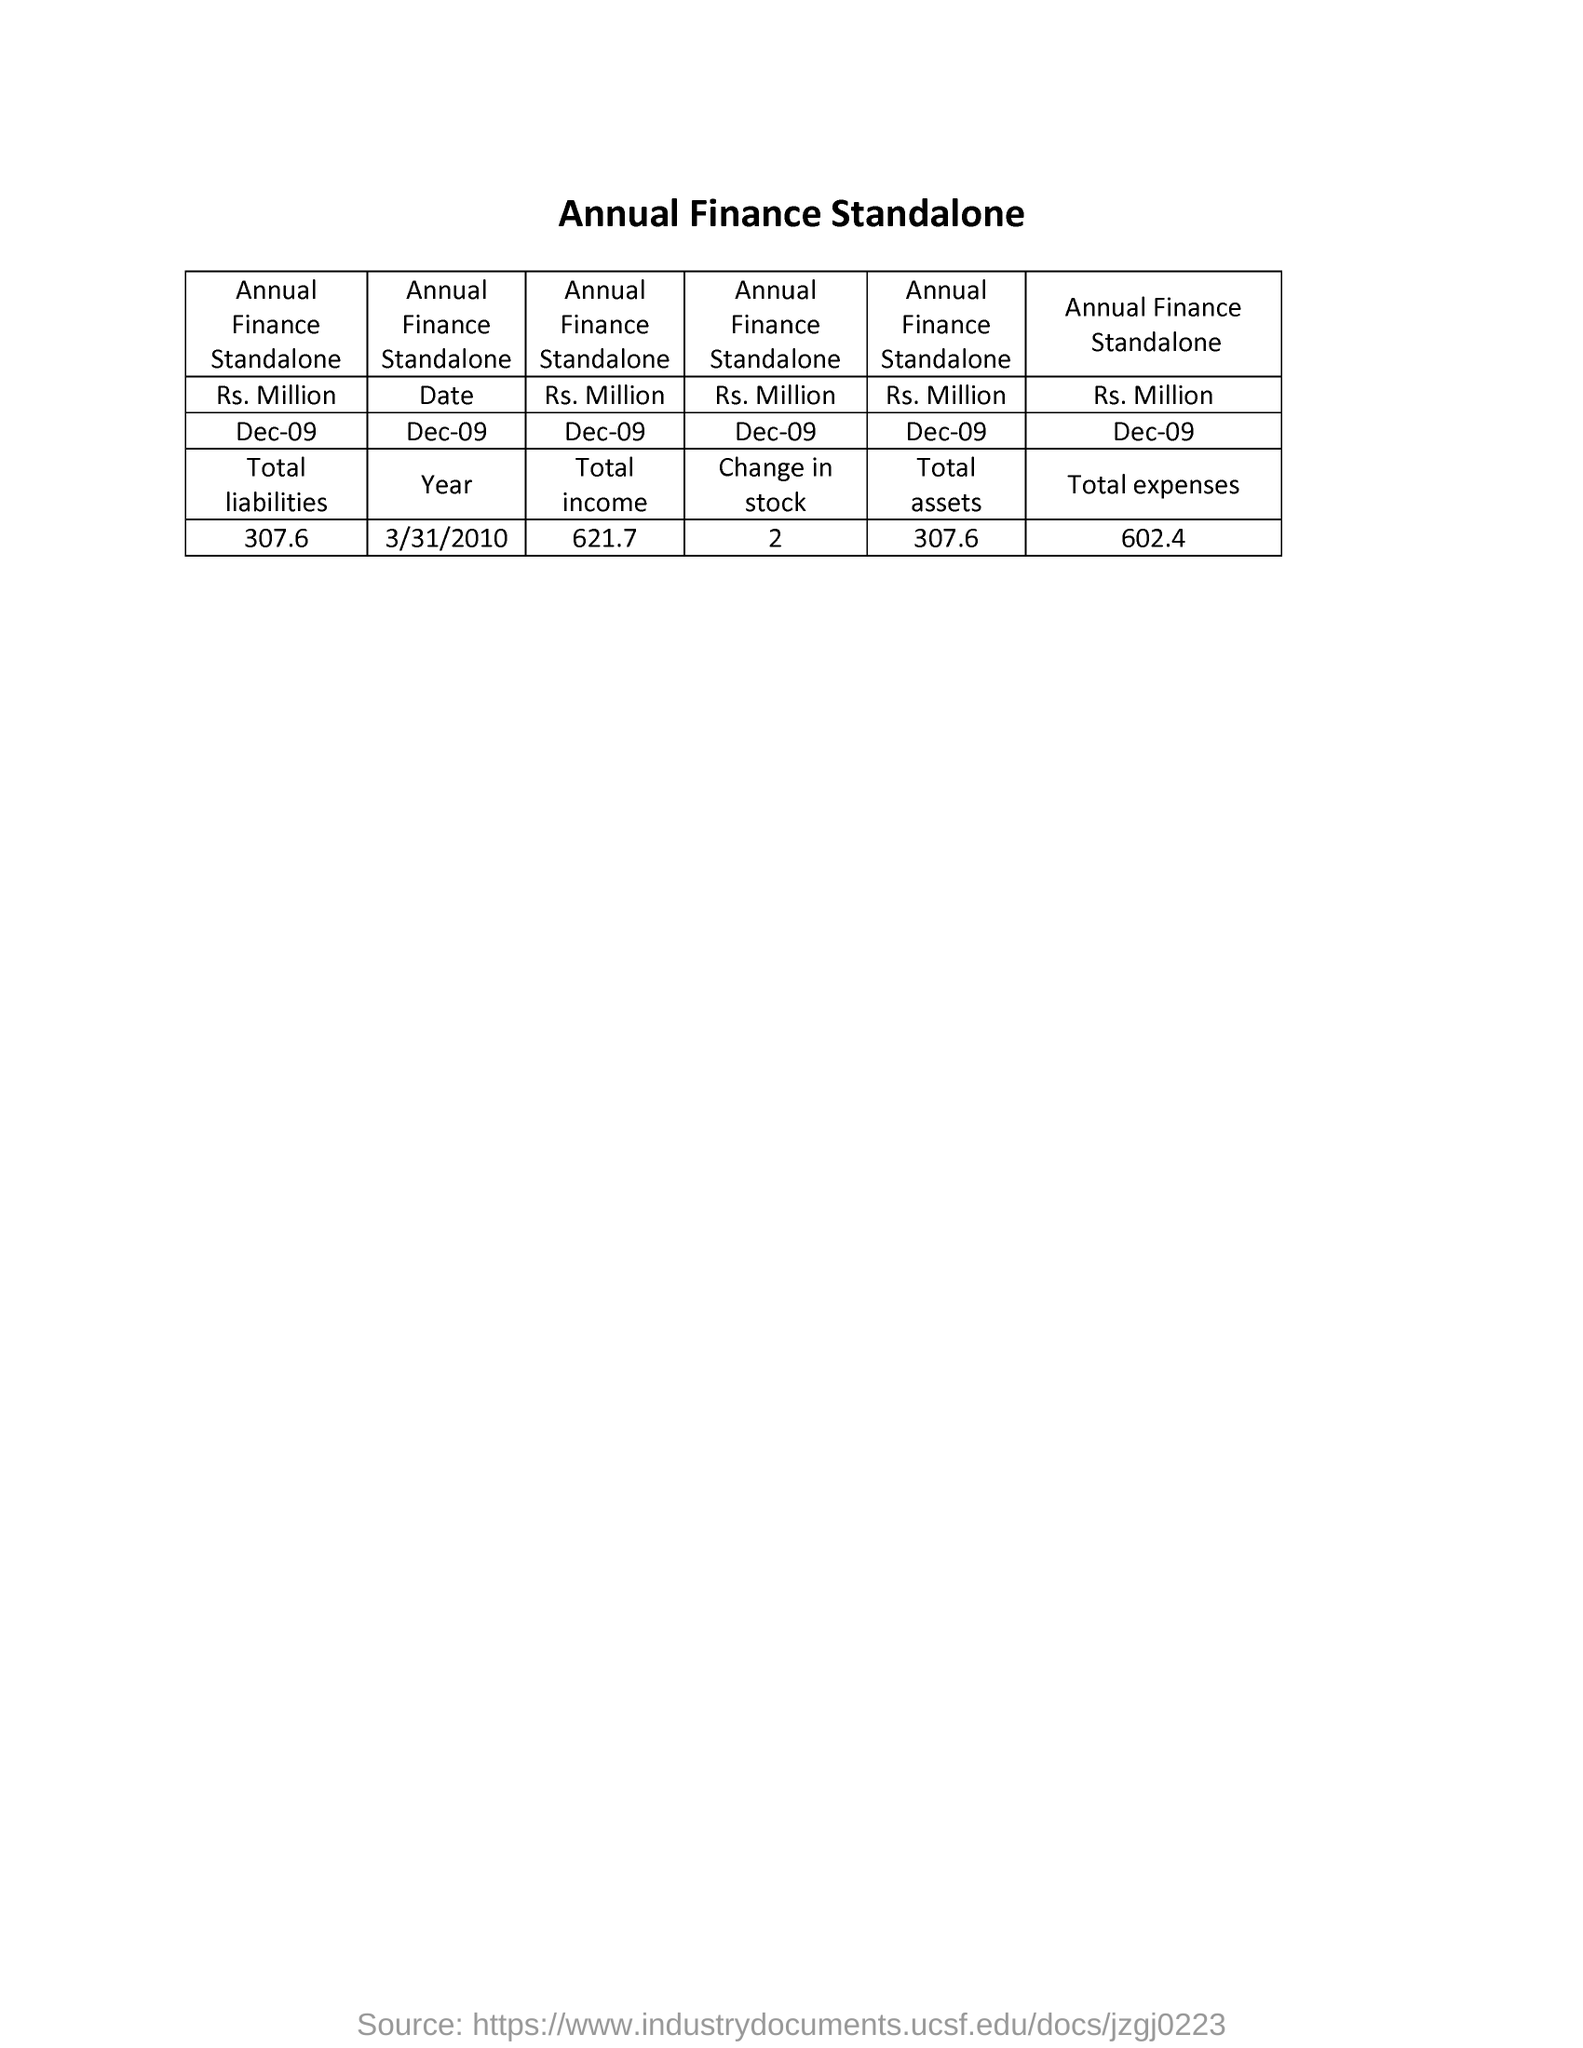Give some essential details in this illustration. The total expenses of the Annual Finance Standalone is 602.4... The value of "Change in stock" is a crucial aspect in the field of accounting and finance. It is a term that is used to describe the difference in the value of a company's assets and liabilities over a specific period of time. This value is essential in determining a company's financial performance, and can provide valuable insights for investors and other stakeholders. The value given under "Total liabilities" is 307.6. The value of the total assets for Annual Finance Standalone is 307.6.. The value of "Total income" is 621.7... 